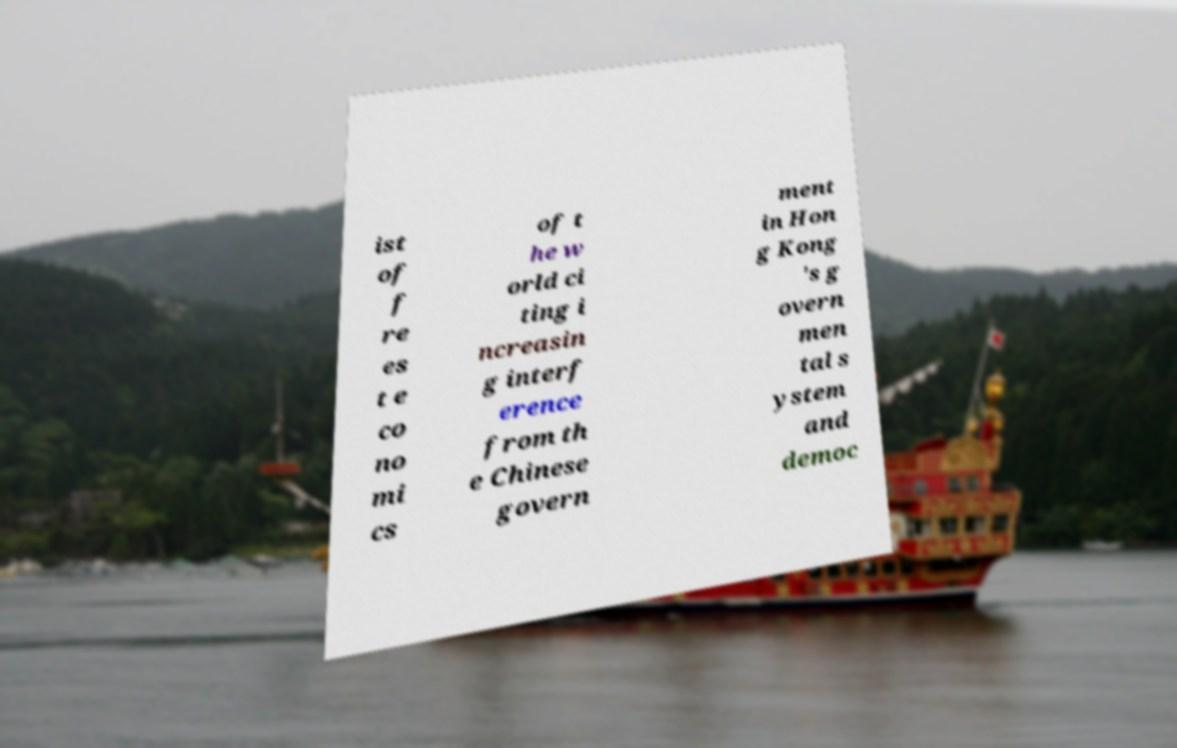Please read and relay the text visible in this image. What does it say? ist of f re es t e co no mi cs of t he w orld ci ting i ncreasin g interf erence from th e Chinese govern ment in Hon g Kong 's g overn men tal s ystem and democ 